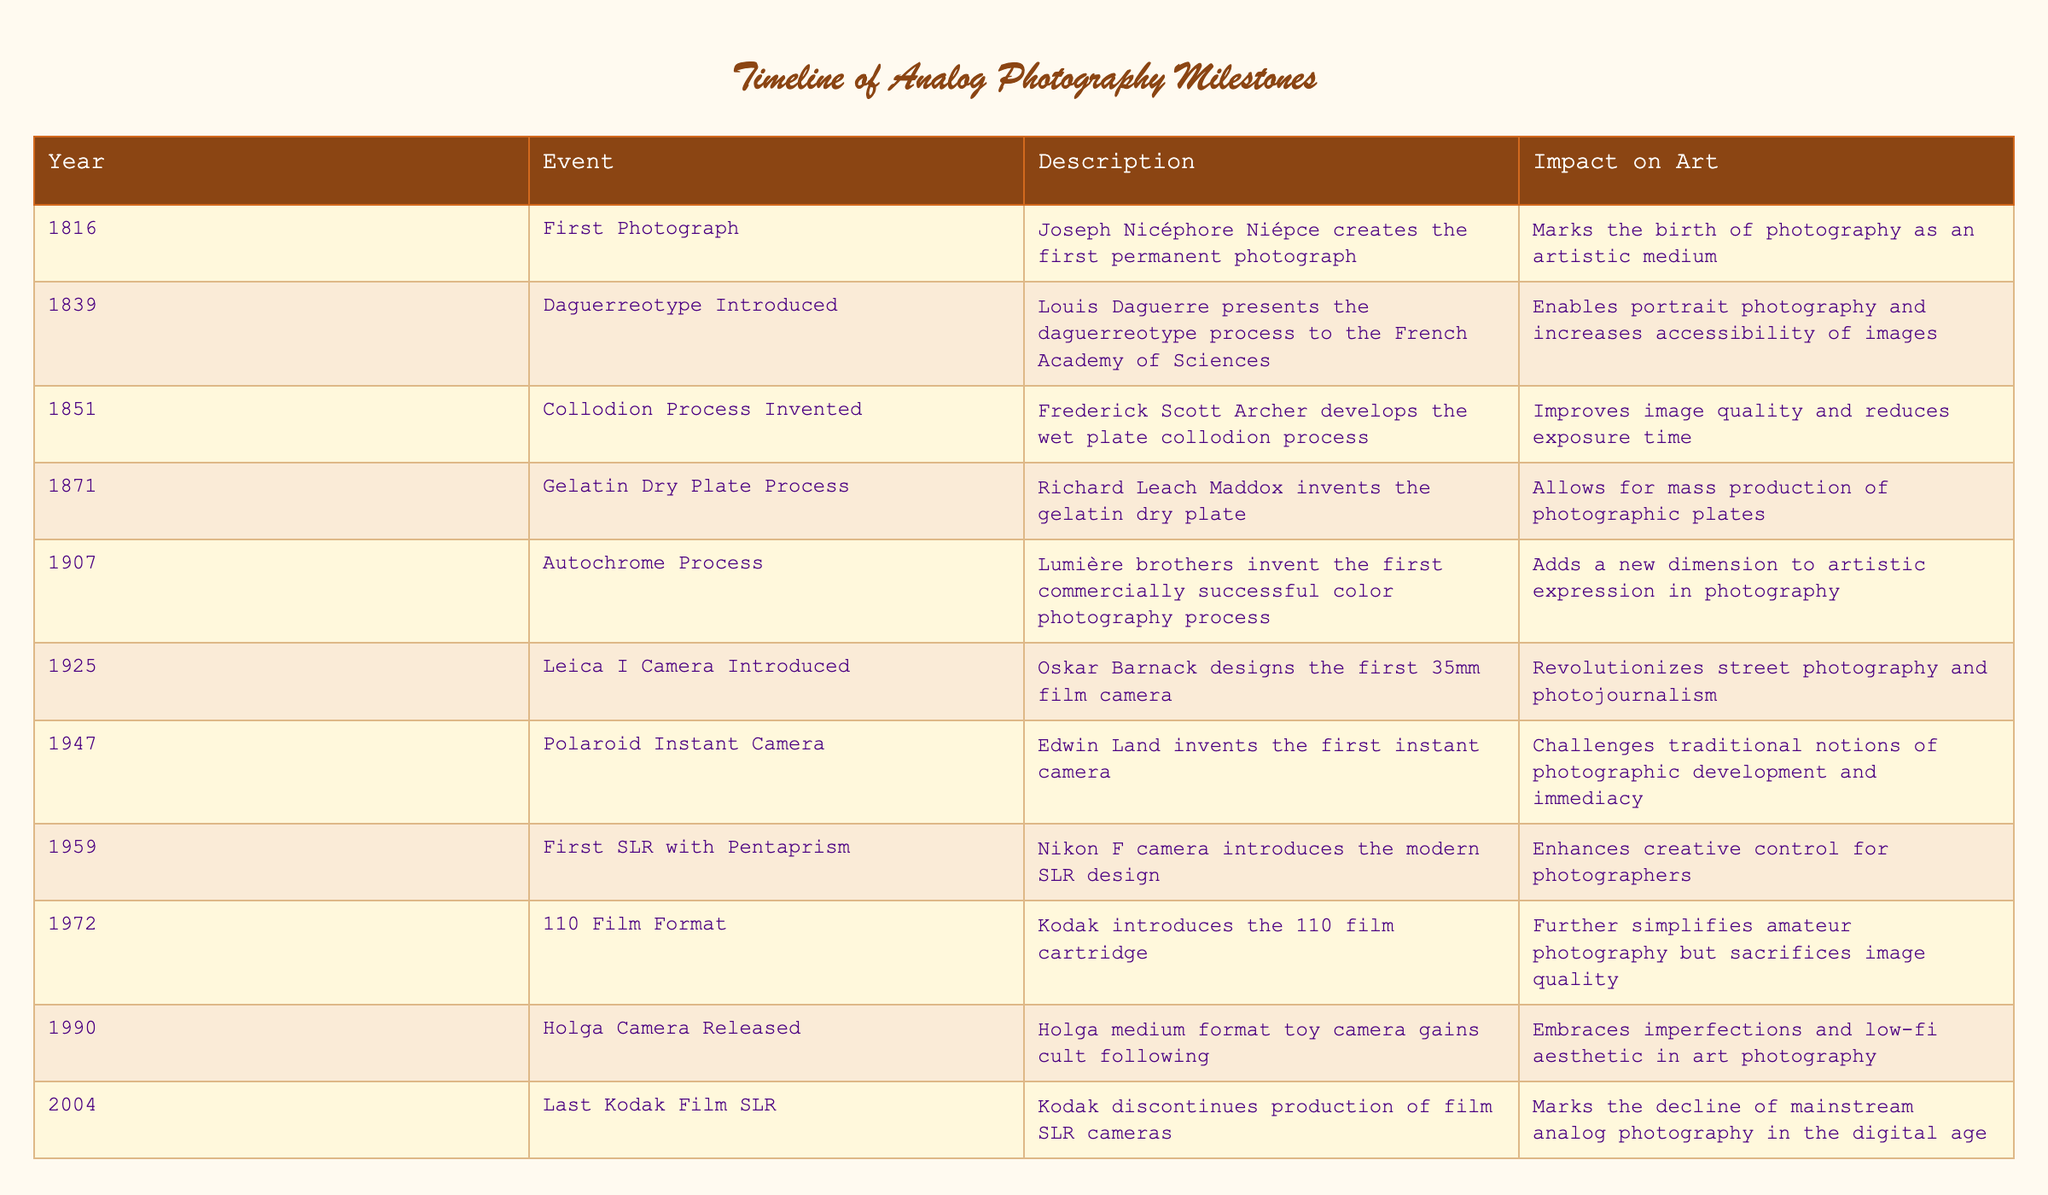What year was the first permanent photograph created? According to the table, the first permanent photograph was created in 1816 by Joseph Nicéphore Niépce.
Answer: 1816 Which event marked the birth of photography as an artistic medium? The birth of photography as an artistic medium was marked by the creation of the first permanent photograph in 1816.
Answer: First Photograph What was the impact of the 1907 Autochrome Process? The 1907 Autochrome process added a new dimension to artistic expression in photography by introducing commercially successful color photography.
Answer: Adds a new dimension to artistic expression How many years passed between the introduction of the Daguerreotype and the invention of the Gelatin Dry Plate Process? The Daguerreotype was introduced in 1839 and the Gelatin Dry Plate Process was invented in 1871. To find the gap: 1871 - 1839 = 32 years.
Answer: 32 years Is the introduction of the Polaroid Instant Camera considered to challenge traditional photographic development? Yes, the introduction of the Polaroid Instant Camera in 1947 is described in the table as challenging traditional notions of photographic development and immediacy.
Answer: Yes What major change did the Leica I Camera introduce in 1925? The Leica I Camera introduced in 1925 revolutionized street photography and photojournalism by being the first 35mm film camera, allowing for more portable and candid photos.
Answer: Revolutionized street photography How many photographic processes were introduced between 1851 and 1907? Looking at the table, the photographic processes introduced between 1851 and 1907 are the Collodion Process (1851), Gelatin Dry Plate Process (1871), and Autochrome Process (1907). There are three events within this time span.
Answer: 3 Did the Holga Camera released in 1990 embrace a low-fi aesthetic in art photography? Yes, according to the table, the Holga medium format toy camera released in 1990 gained a cult following for embracing imperfections and a low-fi aesthetic in art photography.
Answer: Yes What was the significance of Kodak discontinuing film SLR cameras in 2004? The discontinuation of Kodak's film SLR cameras in 2004 marks the decline of mainstream analog photography as the industry shifted towards digital technology, indicating a significant change in the photography landscape.
Answer: Decline of mainstream analog photography 